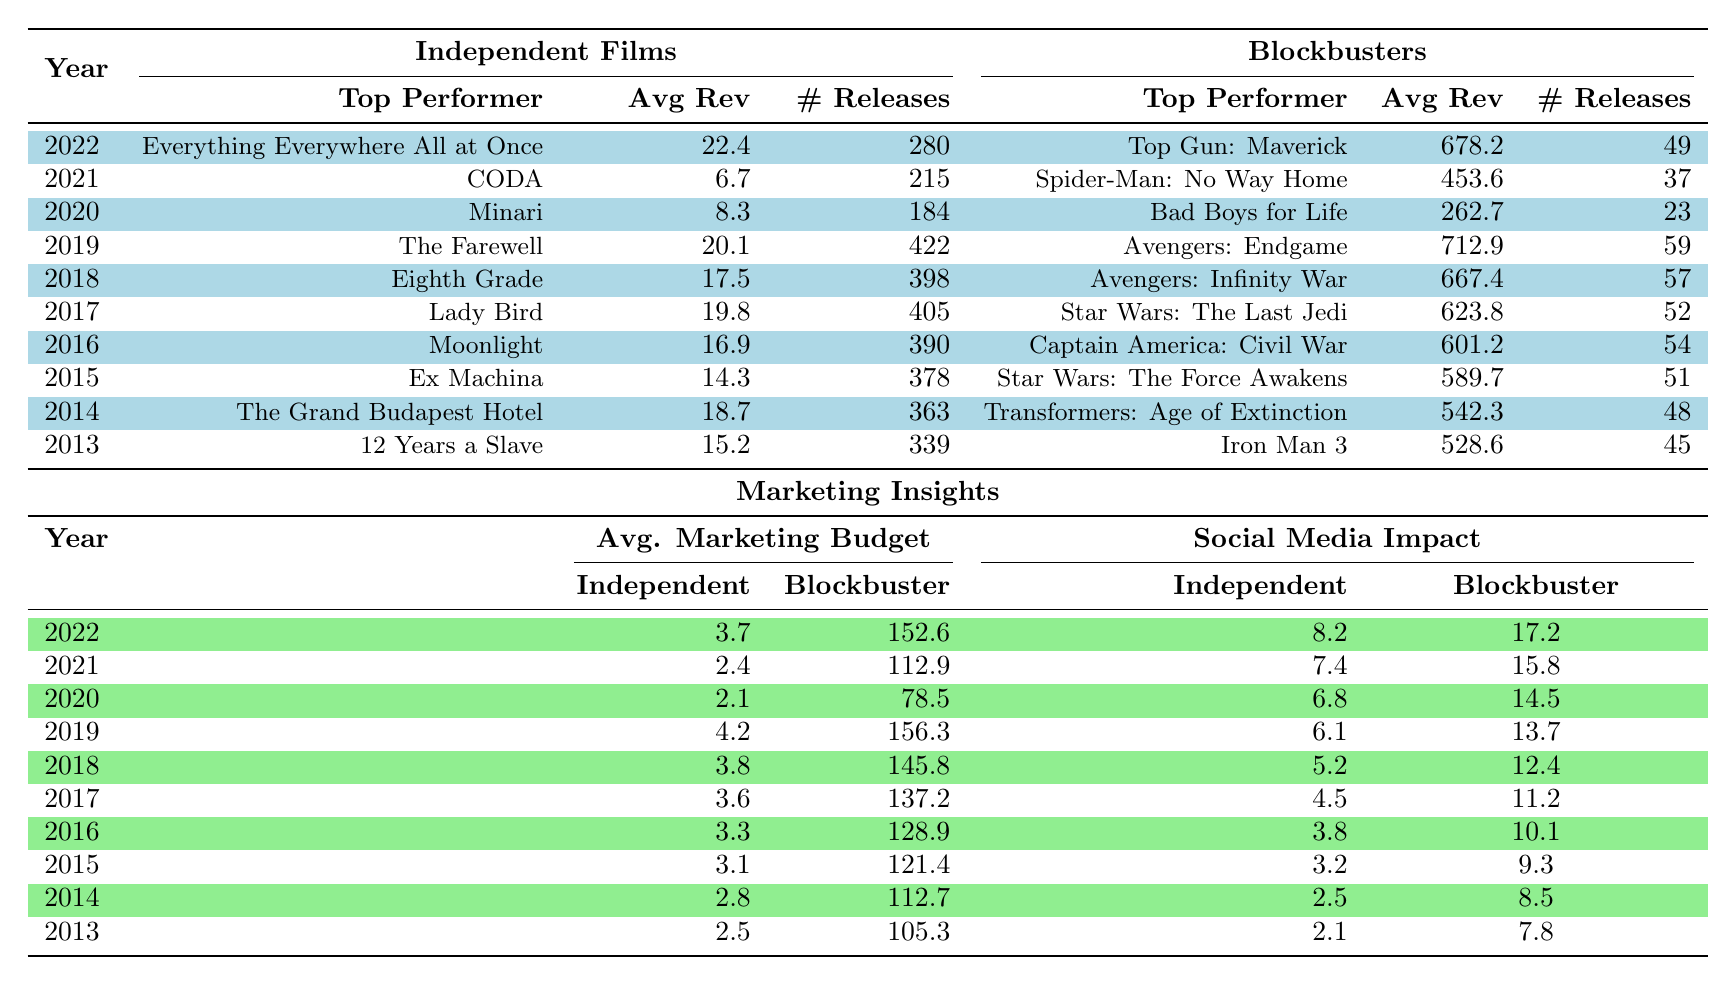What is the top-performing independent film in 2022? The table shows that the top performer for independent films in 2022 is "Everything Everywhere All at Once."
Answer: Everything Everywhere All at Once What was the average revenue of blockbusters in 2015? Referring to the table, in 2015, the average revenue of blockbusters was 589.7 million.
Answer: 589.7 How many independent films were released in 2019? The table indicates that there were 422 independent film releases in 2019.
Answer: 422 What is the difference between the average revenue of independent films and blockbusters in 2020? The average revenue for independent films in 2020 was 8.3 million, while for blockbusters, it was 262.7 million. The difference is 262.7 - 8.3 = 254.4 million.
Answer: 254.4 Did the average marketing budget for independent films increase or decrease from 2013 to 2022? In 2013, the average marketing budget for independent films was 2.5 million, and in 2022 it was 3.7 million. This indicates an increase over the period.
Answer: Increase What year had the highest average revenue for independent films? Looking at the average revenue for independent films across the years, 2022 had the highest average revenue of 22.4 million.
Answer: 2022 What was the top performer among blockbusters in 2018? The top performer for blockbusters in 2018, as per the table, was "Avengers: Infinity War."
Answer: Avengers: Infinity War Which category (independent films or blockbusters) had a greater average marketing budget in 2016? In 2016, the average marketing budget for independent films was 3.3 million, while it was significantly higher for blockbusters at 128.9 million. Hence, blockbusters had the greater average marketing budget.
Answer: Blockbusters What was the overall trend in the average revenue for both independent films and blockbusters from 2013 to 2022? For independent films, the average revenue fluctuated over the years, starting at 15.2 million and ending at 22.4 million. For blockbusters, the average revenue generally increased from 528.6 million to 678.2 million, indicating an upward trend for blockbusters.
Answer: Independent films fluctuated; blockbusters increased What was the total number of releases for both independent films and blockbusters combined in 2017? In 2017, independent films had 405 releases and blockbusters had 52 releases. Adding these gives 405 + 52 = 457 total releases.
Answer: 457 